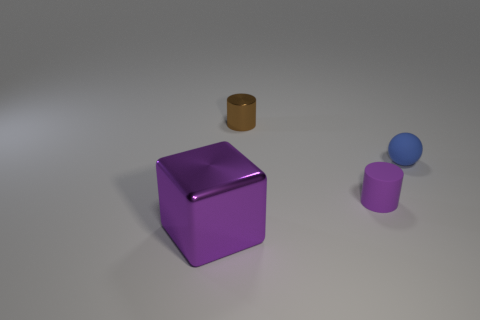Can you describe the lighting and shadows in the scene? The scene is softly lit from above, casting gentle shadows on the surface beneath the objects. The direction and length of the shadows suggest a single light source, likely not directly overhead but slightly to the front of the objects. The purple cube reflects more light, indicating it has a glossier surface, while the other objects have more diffused reflections, which contributes to the perception of the different materials. 